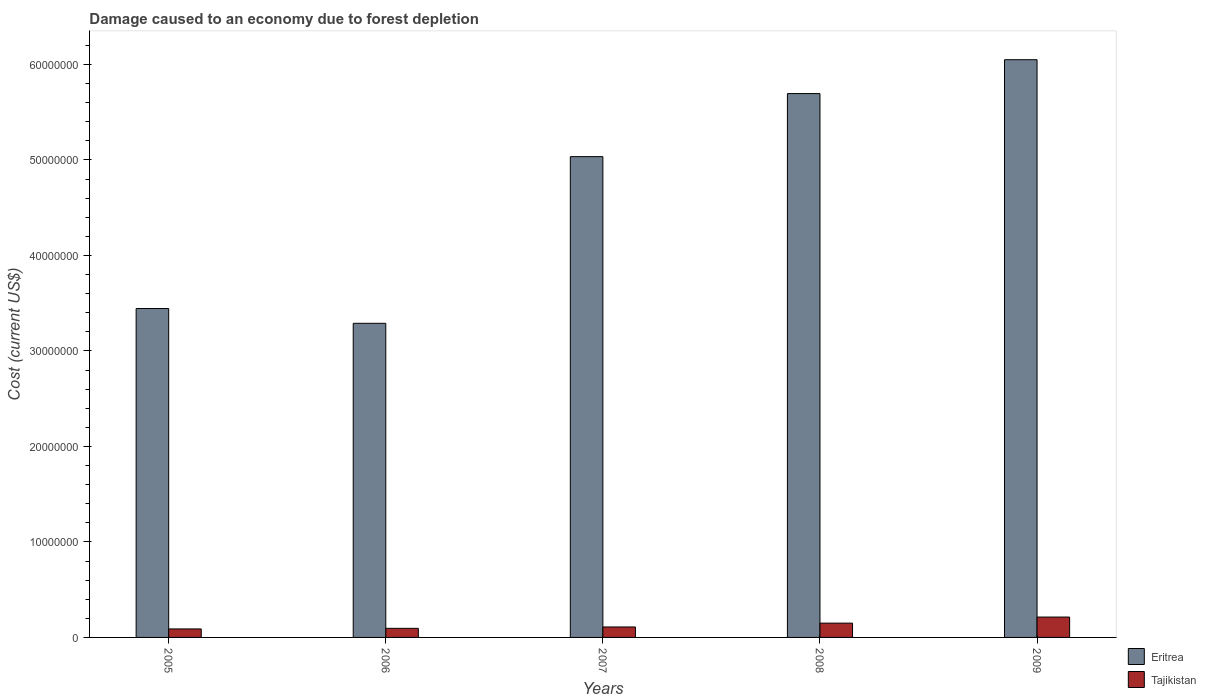How many different coloured bars are there?
Provide a succinct answer. 2. How many groups of bars are there?
Make the answer very short. 5. Are the number of bars per tick equal to the number of legend labels?
Ensure brevity in your answer.  Yes. How many bars are there on the 1st tick from the right?
Ensure brevity in your answer.  2. What is the label of the 3rd group of bars from the left?
Provide a short and direct response. 2007. In how many cases, is the number of bars for a given year not equal to the number of legend labels?
Provide a succinct answer. 0. What is the cost of damage caused due to forest depletion in Eritrea in 2006?
Give a very brief answer. 3.29e+07. Across all years, what is the maximum cost of damage caused due to forest depletion in Tajikistan?
Give a very brief answer. 2.13e+06. Across all years, what is the minimum cost of damage caused due to forest depletion in Tajikistan?
Provide a short and direct response. 8.90e+05. In which year was the cost of damage caused due to forest depletion in Eritrea maximum?
Offer a terse response. 2009. What is the total cost of damage caused due to forest depletion in Tajikistan in the graph?
Give a very brief answer. 6.57e+06. What is the difference between the cost of damage caused due to forest depletion in Tajikistan in 2007 and that in 2008?
Offer a terse response. -4.01e+05. What is the difference between the cost of damage caused due to forest depletion in Eritrea in 2007 and the cost of damage caused due to forest depletion in Tajikistan in 2006?
Provide a short and direct response. 4.94e+07. What is the average cost of damage caused due to forest depletion in Tajikistan per year?
Your answer should be compact. 1.31e+06. In the year 2005, what is the difference between the cost of damage caused due to forest depletion in Eritrea and cost of damage caused due to forest depletion in Tajikistan?
Provide a short and direct response. 3.36e+07. What is the ratio of the cost of damage caused due to forest depletion in Eritrea in 2005 to that in 2008?
Your answer should be very brief. 0.6. Is the cost of damage caused due to forest depletion in Eritrea in 2007 less than that in 2009?
Provide a short and direct response. Yes. Is the difference between the cost of damage caused due to forest depletion in Eritrea in 2005 and 2007 greater than the difference between the cost of damage caused due to forest depletion in Tajikistan in 2005 and 2007?
Provide a short and direct response. No. What is the difference between the highest and the second highest cost of damage caused due to forest depletion in Eritrea?
Keep it short and to the point. 3.55e+06. What is the difference between the highest and the lowest cost of damage caused due to forest depletion in Eritrea?
Make the answer very short. 2.76e+07. What does the 1st bar from the left in 2009 represents?
Ensure brevity in your answer.  Eritrea. What does the 2nd bar from the right in 2007 represents?
Offer a terse response. Eritrea. Are all the bars in the graph horizontal?
Provide a succinct answer. No. What is the difference between two consecutive major ticks on the Y-axis?
Ensure brevity in your answer.  1.00e+07. Are the values on the major ticks of Y-axis written in scientific E-notation?
Keep it short and to the point. No. Does the graph contain any zero values?
Your answer should be compact. No. Does the graph contain grids?
Provide a short and direct response. No. How are the legend labels stacked?
Ensure brevity in your answer.  Vertical. What is the title of the graph?
Your answer should be compact. Damage caused to an economy due to forest depletion. Does "Faeroe Islands" appear as one of the legend labels in the graph?
Keep it short and to the point. No. What is the label or title of the X-axis?
Ensure brevity in your answer.  Years. What is the label or title of the Y-axis?
Provide a succinct answer. Cost (current US$). What is the Cost (current US$) of Eritrea in 2005?
Provide a short and direct response. 3.44e+07. What is the Cost (current US$) in Tajikistan in 2005?
Offer a very short reply. 8.90e+05. What is the Cost (current US$) of Eritrea in 2006?
Ensure brevity in your answer.  3.29e+07. What is the Cost (current US$) in Tajikistan in 2006?
Ensure brevity in your answer.  9.51e+05. What is the Cost (current US$) of Eritrea in 2007?
Keep it short and to the point. 5.03e+07. What is the Cost (current US$) of Tajikistan in 2007?
Keep it short and to the point. 1.10e+06. What is the Cost (current US$) of Eritrea in 2008?
Provide a succinct answer. 5.70e+07. What is the Cost (current US$) in Tajikistan in 2008?
Your response must be concise. 1.50e+06. What is the Cost (current US$) of Eritrea in 2009?
Your answer should be very brief. 6.05e+07. What is the Cost (current US$) of Tajikistan in 2009?
Keep it short and to the point. 2.13e+06. Across all years, what is the maximum Cost (current US$) of Eritrea?
Make the answer very short. 6.05e+07. Across all years, what is the maximum Cost (current US$) in Tajikistan?
Your answer should be compact. 2.13e+06. Across all years, what is the minimum Cost (current US$) in Eritrea?
Make the answer very short. 3.29e+07. Across all years, what is the minimum Cost (current US$) in Tajikistan?
Provide a short and direct response. 8.90e+05. What is the total Cost (current US$) of Eritrea in the graph?
Your answer should be very brief. 2.35e+08. What is the total Cost (current US$) in Tajikistan in the graph?
Ensure brevity in your answer.  6.57e+06. What is the difference between the Cost (current US$) of Eritrea in 2005 and that in 2006?
Offer a terse response. 1.55e+06. What is the difference between the Cost (current US$) of Tajikistan in 2005 and that in 2006?
Ensure brevity in your answer.  -6.13e+04. What is the difference between the Cost (current US$) in Eritrea in 2005 and that in 2007?
Offer a terse response. -1.59e+07. What is the difference between the Cost (current US$) of Tajikistan in 2005 and that in 2007?
Offer a terse response. -2.07e+05. What is the difference between the Cost (current US$) of Eritrea in 2005 and that in 2008?
Your response must be concise. -2.25e+07. What is the difference between the Cost (current US$) of Tajikistan in 2005 and that in 2008?
Give a very brief answer. -6.07e+05. What is the difference between the Cost (current US$) in Eritrea in 2005 and that in 2009?
Offer a terse response. -2.61e+07. What is the difference between the Cost (current US$) of Tajikistan in 2005 and that in 2009?
Your answer should be compact. -1.24e+06. What is the difference between the Cost (current US$) in Eritrea in 2006 and that in 2007?
Your response must be concise. -1.75e+07. What is the difference between the Cost (current US$) in Tajikistan in 2006 and that in 2007?
Keep it short and to the point. -1.45e+05. What is the difference between the Cost (current US$) of Eritrea in 2006 and that in 2008?
Your answer should be very brief. -2.41e+07. What is the difference between the Cost (current US$) in Tajikistan in 2006 and that in 2008?
Provide a short and direct response. -5.46e+05. What is the difference between the Cost (current US$) of Eritrea in 2006 and that in 2009?
Your response must be concise. -2.76e+07. What is the difference between the Cost (current US$) of Tajikistan in 2006 and that in 2009?
Make the answer very short. -1.18e+06. What is the difference between the Cost (current US$) in Eritrea in 2007 and that in 2008?
Your response must be concise. -6.60e+06. What is the difference between the Cost (current US$) in Tajikistan in 2007 and that in 2008?
Offer a very short reply. -4.01e+05. What is the difference between the Cost (current US$) in Eritrea in 2007 and that in 2009?
Provide a succinct answer. -1.01e+07. What is the difference between the Cost (current US$) in Tajikistan in 2007 and that in 2009?
Keep it short and to the point. -1.04e+06. What is the difference between the Cost (current US$) in Eritrea in 2008 and that in 2009?
Your response must be concise. -3.55e+06. What is the difference between the Cost (current US$) in Tajikistan in 2008 and that in 2009?
Give a very brief answer. -6.36e+05. What is the difference between the Cost (current US$) in Eritrea in 2005 and the Cost (current US$) in Tajikistan in 2006?
Offer a terse response. 3.35e+07. What is the difference between the Cost (current US$) in Eritrea in 2005 and the Cost (current US$) in Tajikistan in 2007?
Give a very brief answer. 3.33e+07. What is the difference between the Cost (current US$) in Eritrea in 2005 and the Cost (current US$) in Tajikistan in 2008?
Provide a succinct answer. 3.29e+07. What is the difference between the Cost (current US$) of Eritrea in 2005 and the Cost (current US$) of Tajikistan in 2009?
Make the answer very short. 3.23e+07. What is the difference between the Cost (current US$) of Eritrea in 2006 and the Cost (current US$) of Tajikistan in 2007?
Give a very brief answer. 3.18e+07. What is the difference between the Cost (current US$) of Eritrea in 2006 and the Cost (current US$) of Tajikistan in 2008?
Make the answer very short. 3.14e+07. What is the difference between the Cost (current US$) of Eritrea in 2006 and the Cost (current US$) of Tajikistan in 2009?
Provide a succinct answer. 3.08e+07. What is the difference between the Cost (current US$) of Eritrea in 2007 and the Cost (current US$) of Tajikistan in 2008?
Offer a terse response. 4.89e+07. What is the difference between the Cost (current US$) of Eritrea in 2007 and the Cost (current US$) of Tajikistan in 2009?
Provide a short and direct response. 4.82e+07. What is the difference between the Cost (current US$) in Eritrea in 2008 and the Cost (current US$) in Tajikistan in 2009?
Your answer should be very brief. 5.48e+07. What is the average Cost (current US$) in Eritrea per year?
Provide a short and direct response. 4.70e+07. What is the average Cost (current US$) of Tajikistan per year?
Make the answer very short. 1.31e+06. In the year 2005, what is the difference between the Cost (current US$) in Eritrea and Cost (current US$) in Tajikistan?
Give a very brief answer. 3.36e+07. In the year 2006, what is the difference between the Cost (current US$) in Eritrea and Cost (current US$) in Tajikistan?
Your answer should be compact. 3.19e+07. In the year 2007, what is the difference between the Cost (current US$) of Eritrea and Cost (current US$) of Tajikistan?
Give a very brief answer. 4.93e+07. In the year 2008, what is the difference between the Cost (current US$) of Eritrea and Cost (current US$) of Tajikistan?
Your answer should be compact. 5.55e+07. In the year 2009, what is the difference between the Cost (current US$) of Eritrea and Cost (current US$) of Tajikistan?
Your answer should be very brief. 5.84e+07. What is the ratio of the Cost (current US$) in Eritrea in 2005 to that in 2006?
Your response must be concise. 1.05. What is the ratio of the Cost (current US$) of Tajikistan in 2005 to that in 2006?
Offer a very short reply. 0.94. What is the ratio of the Cost (current US$) of Eritrea in 2005 to that in 2007?
Ensure brevity in your answer.  0.68. What is the ratio of the Cost (current US$) in Tajikistan in 2005 to that in 2007?
Your answer should be very brief. 0.81. What is the ratio of the Cost (current US$) in Eritrea in 2005 to that in 2008?
Your answer should be compact. 0.6. What is the ratio of the Cost (current US$) in Tajikistan in 2005 to that in 2008?
Keep it short and to the point. 0.59. What is the ratio of the Cost (current US$) in Eritrea in 2005 to that in 2009?
Your answer should be compact. 0.57. What is the ratio of the Cost (current US$) in Tajikistan in 2005 to that in 2009?
Give a very brief answer. 0.42. What is the ratio of the Cost (current US$) in Eritrea in 2006 to that in 2007?
Your answer should be very brief. 0.65. What is the ratio of the Cost (current US$) of Tajikistan in 2006 to that in 2007?
Offer a very short reply. 0.87. What is the ratio of the Cost (current US$) of Eritrea in 2006 to that in 2008?
Give a very brief answer. 0.58. What is the ratio of the Cost (current US$) of Tajikistan in 2006 to that in 2008?
Your answer should be very brief. 0.64. What is the ratio of the Cost (current US$) of Eritrea in 2006 to that in 2009?
Offer a terse response. 0.54. What is the ratio of the Cost (current US$) in Tajikistan in 2006 to that in 2009?
Keep it short and to the point. 0.45. What is the ratio of the Cost (current US$) in Eritrea in 2007 to that in 2008?
Offer a terse response. 0.88. What is the ratio of the Cost (current US$) in Tajikistan in 2007 to that in 2008?
Keep it short and to the point. 0.73. What is the ratio of the Cost (current US$) of Eritrea in 2007 to that in 2009?
Your answer should be very brief. 0.83. What is the ratio of the Cost (current US$) in Tajikistan in 2007 to that in 2009?
Give a very brief answer. 0.51. What is the ratio of the Cost (current US$) in Eritrea in 2008 to that in 2009?
Provide a succinct answer. 0.94. What is the ratio of the Cost (current US$) in Tajikistan in 2008 to that in 2009?
Ensure brevity in your answer.  0.7. What is the difference between the highest and the second highest Cost (current US$) in Eritrea?
Your answer should be compact. 3.55e+06. What is the difference between the highest and the second highest Cost (current US$) in Tajikistan?
Provide a short and direct response. 6.36e+05. What is the difference between the highest and the lowest Cost (current US$) of Eritrea?
Make the answer very short. 2.76e+07. What is the difference between the highest and the lowest Cost (current US$) in Tajikistan?
Your answer should be compact. 1.24e+06. 